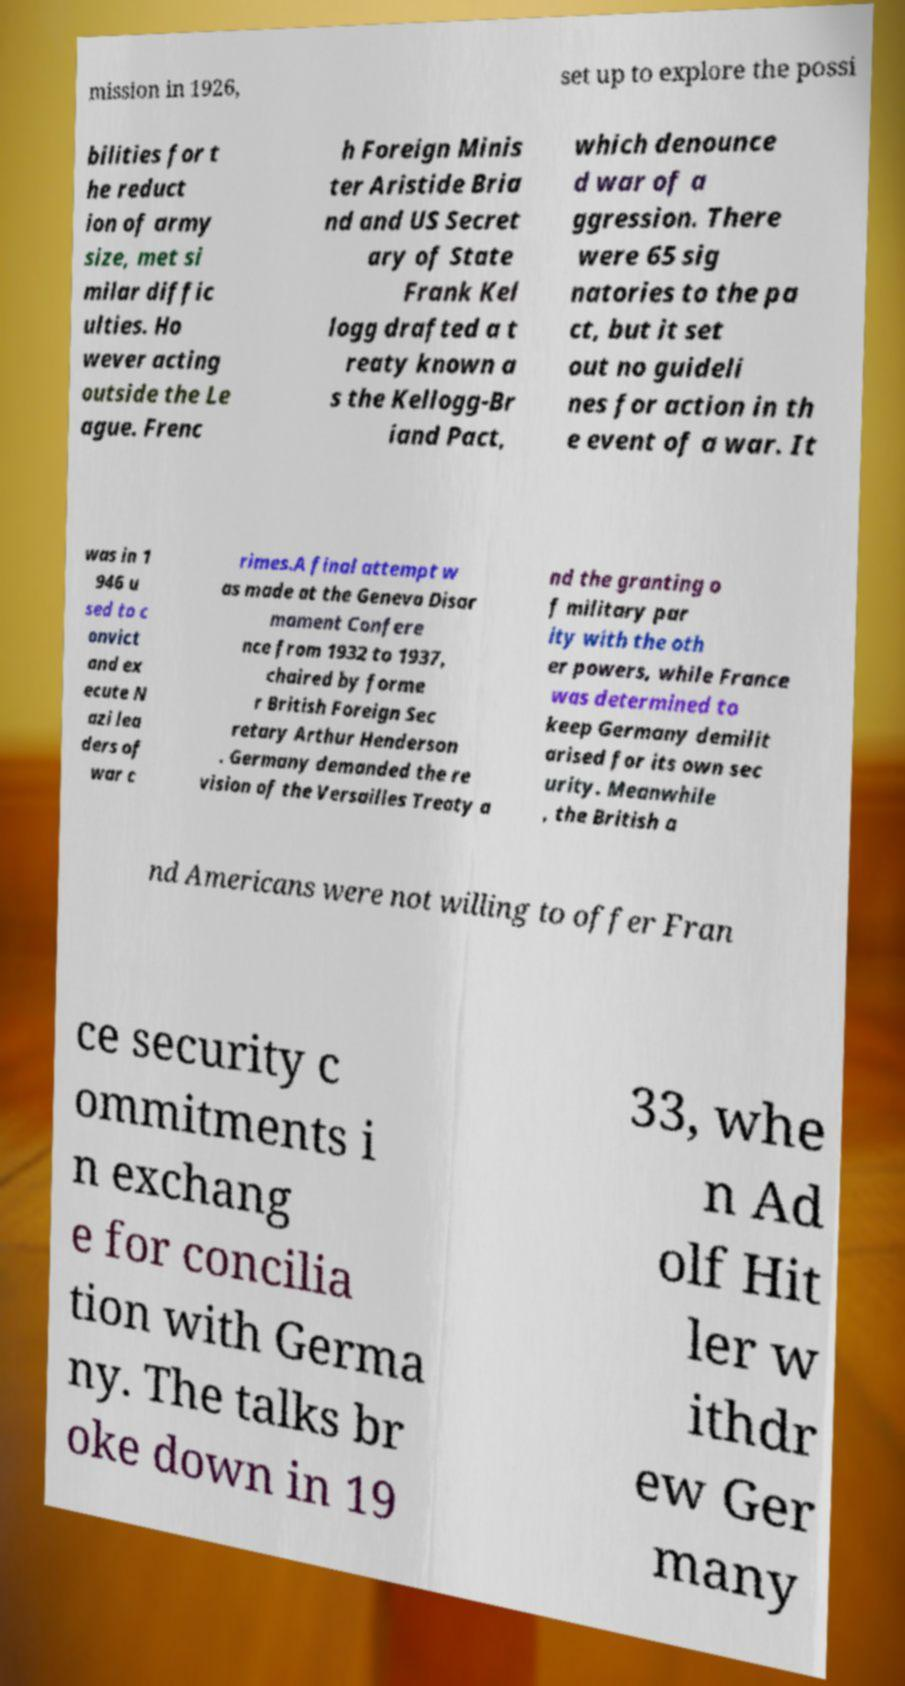Can you read and provide the text displayed in the image?This photo seems to have some interesting text. Can you extract and type it out for me? mission in 1926, set up to explore the possi bilities for t he reduct ion of army size, met si milar diffic ulties. Ho wever acting outside the Le ague. Frenc h Foreign Minis ter Aristide Bria nd and US Secret ary of State Frank Kel logg drafted a t reaty known a s the Kellogg-Br iand Pact, which denounce d war of a ggression. There were 65 sig natories to the pa ct, but it set out no guideli nes for action in th e event of a war. It was in 1 946 u sed to c onvict and ex ecute N azi lea ders of war c rimes.A final attempt w as made at the Geneva Disar mament Confere nce from 1932 to 1937, chaired by forme r British Foreign Sec retary Arthur Henderson . Germany demanded the re vision of the Versailles Treaty a nd the granting o f military par ity with the oth er powers, while France was determined to keep Germany demilit arised for its own sec urity. Meanwhile , the British a nd Americans were not willing to offer Fran ce security c ommitments i n exchang e for concilia tion with Germa ny. The talks br oke down in 19 33, whe n Ad olf Hit ler w ithdr ew Ger many 